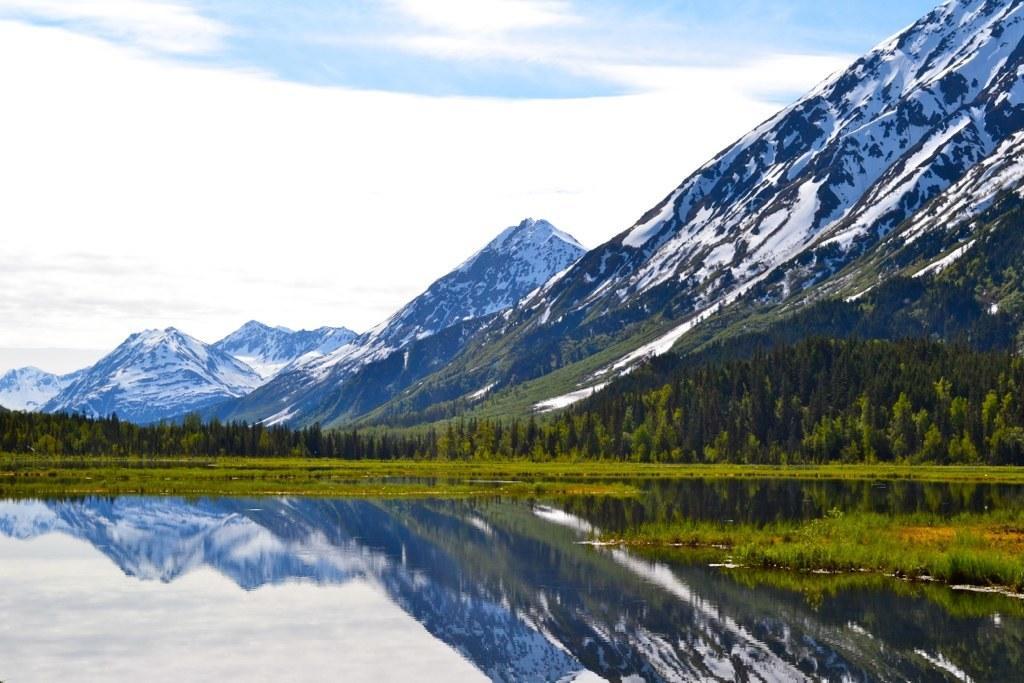In one or two sentences, can you explain what this image depicts? There is water, near grass on the ground and trees. In the background, there are snow mountains and clouds in the blue sky. 